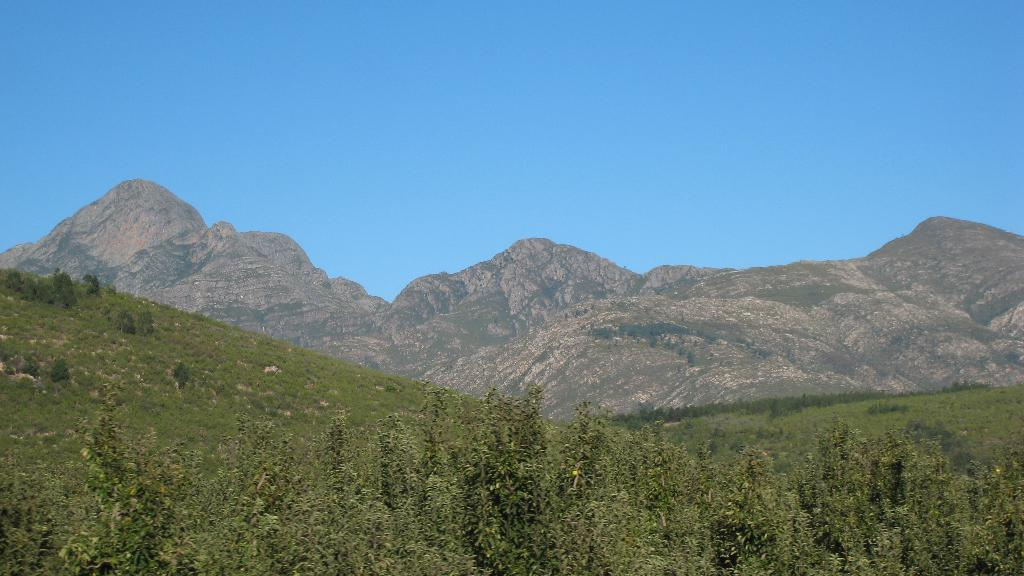What color is the sky in the image? The sky is blue in the image. What can be seen in the background of the image? There are mountains in the distance. What type of vegetation covers the land in the image? The land is covered with grass. Can you identify any specific plant in the image? Yes, there is a tree visible in the image. How many sticks are being used to create a quiet atmosphere in the image? There are no sticks or any indication of a quiet atmosphere present in the image. 